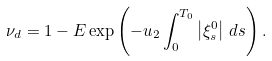<formula> <loc_0><loc_0><loc_500><loc_500>\nu _ { d } = 1 - E \exp \left ( - u _ { 2 } \int _ { 0 } ^ { T _ { 0 } } \left | \xi _ { s } ^ { 0 } \right | \, d s \right ) .</formula> 